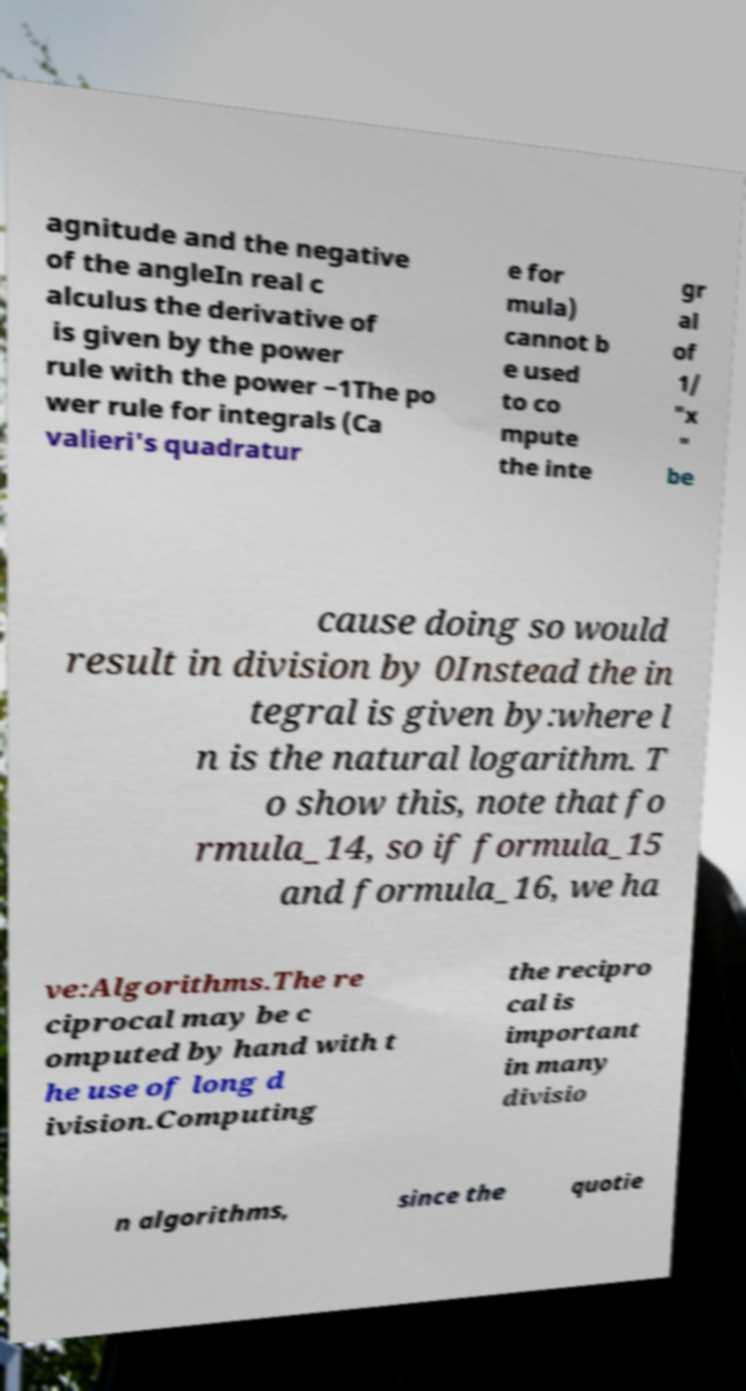Please read and relay the text visible in this image. What does it say? agnitude and the negative of the angleIn real c alculus the derivative of is given by the power rule with the power −1The po wer rule for integrals (Ca valieri's quadratur e for mula) cannot b e used to co mpute the inte gr al of 1/ "x " be cause doing so would result in division by 0Instead the in tegral is given by:where l n is the natural logarithm. T o show this, note that fo rmula_14, so if formula_15 and formula_16, we ha ve:Algorithms.The re ciprocal may be c omputed by hand with t he use of long d ivision.Computing the recipro cal is important in many divisio n algorithms, since the quotie 